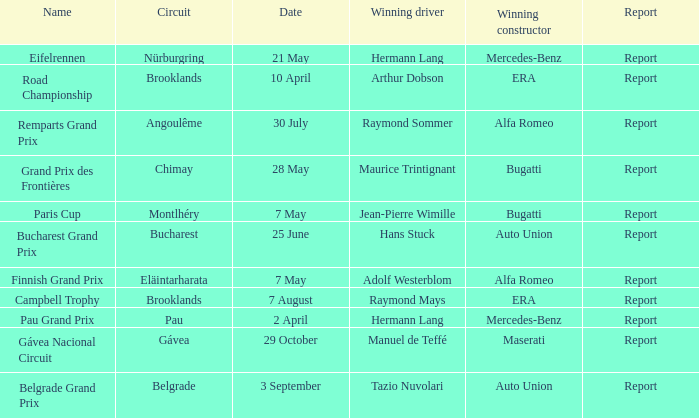Tell me the winning constructor for the paris cup Bugatti. Would you mind parsing the complete table? {'header': ['Name', 'Circuit', 'Date', 'Winning driver', 'Winning constructor', 'Report'], 'rows': [['Eifelrennen', 'Nürburgring', '21 May', 'Hermann Lang', 'Mercedes-Benz', 'Report'], ['Road Championship', 'Brooklands', '10 April', 'Arthur Dobson', 'ERA', 'Report'], ['Remparts Grand Prix', 'Angoulême', '30 July', 'Raymond Sommer', 'Alfa Romeo', 'Report'], ['Grand Prix des Frontières', 'Chimay', '28 May', 'Maurice Trintignant', 'Bugatti', 'Report'], ['Paris Cup', 'Montlhéry', '7 May', 'Jean-Pierre Wimille', 'Bugatti', 'Report'], ['Bucharest Grand Prix', 'Bucharest', '25 June', 'Hans Stuck', 'Auto Union', 'Report'], ['Finnish Grand Prix', 'Eläintarharata', '7 May', 'Adolf Westerblom', 'Alfa Romeo', 'Report'], ['Campbell Trophy', 'Brooklands', '7 August', 'Raymond Mays', 'ERA', 'Report'], ['Pau Grand Prix', 'Pau', '2 April', 'Hermann Lang', 'Mercedes-Benz', 'Report'], ['Gávea Nacional Circuit', 'Gávea', '29 October', 'Manuel de Teffé', 'Maserati', 'Report'], ['Belgrade Grand Prix', 'Belgrade', '3 September', 'Tazio Nuvolari', 'Auto Union', 'Report']]} 